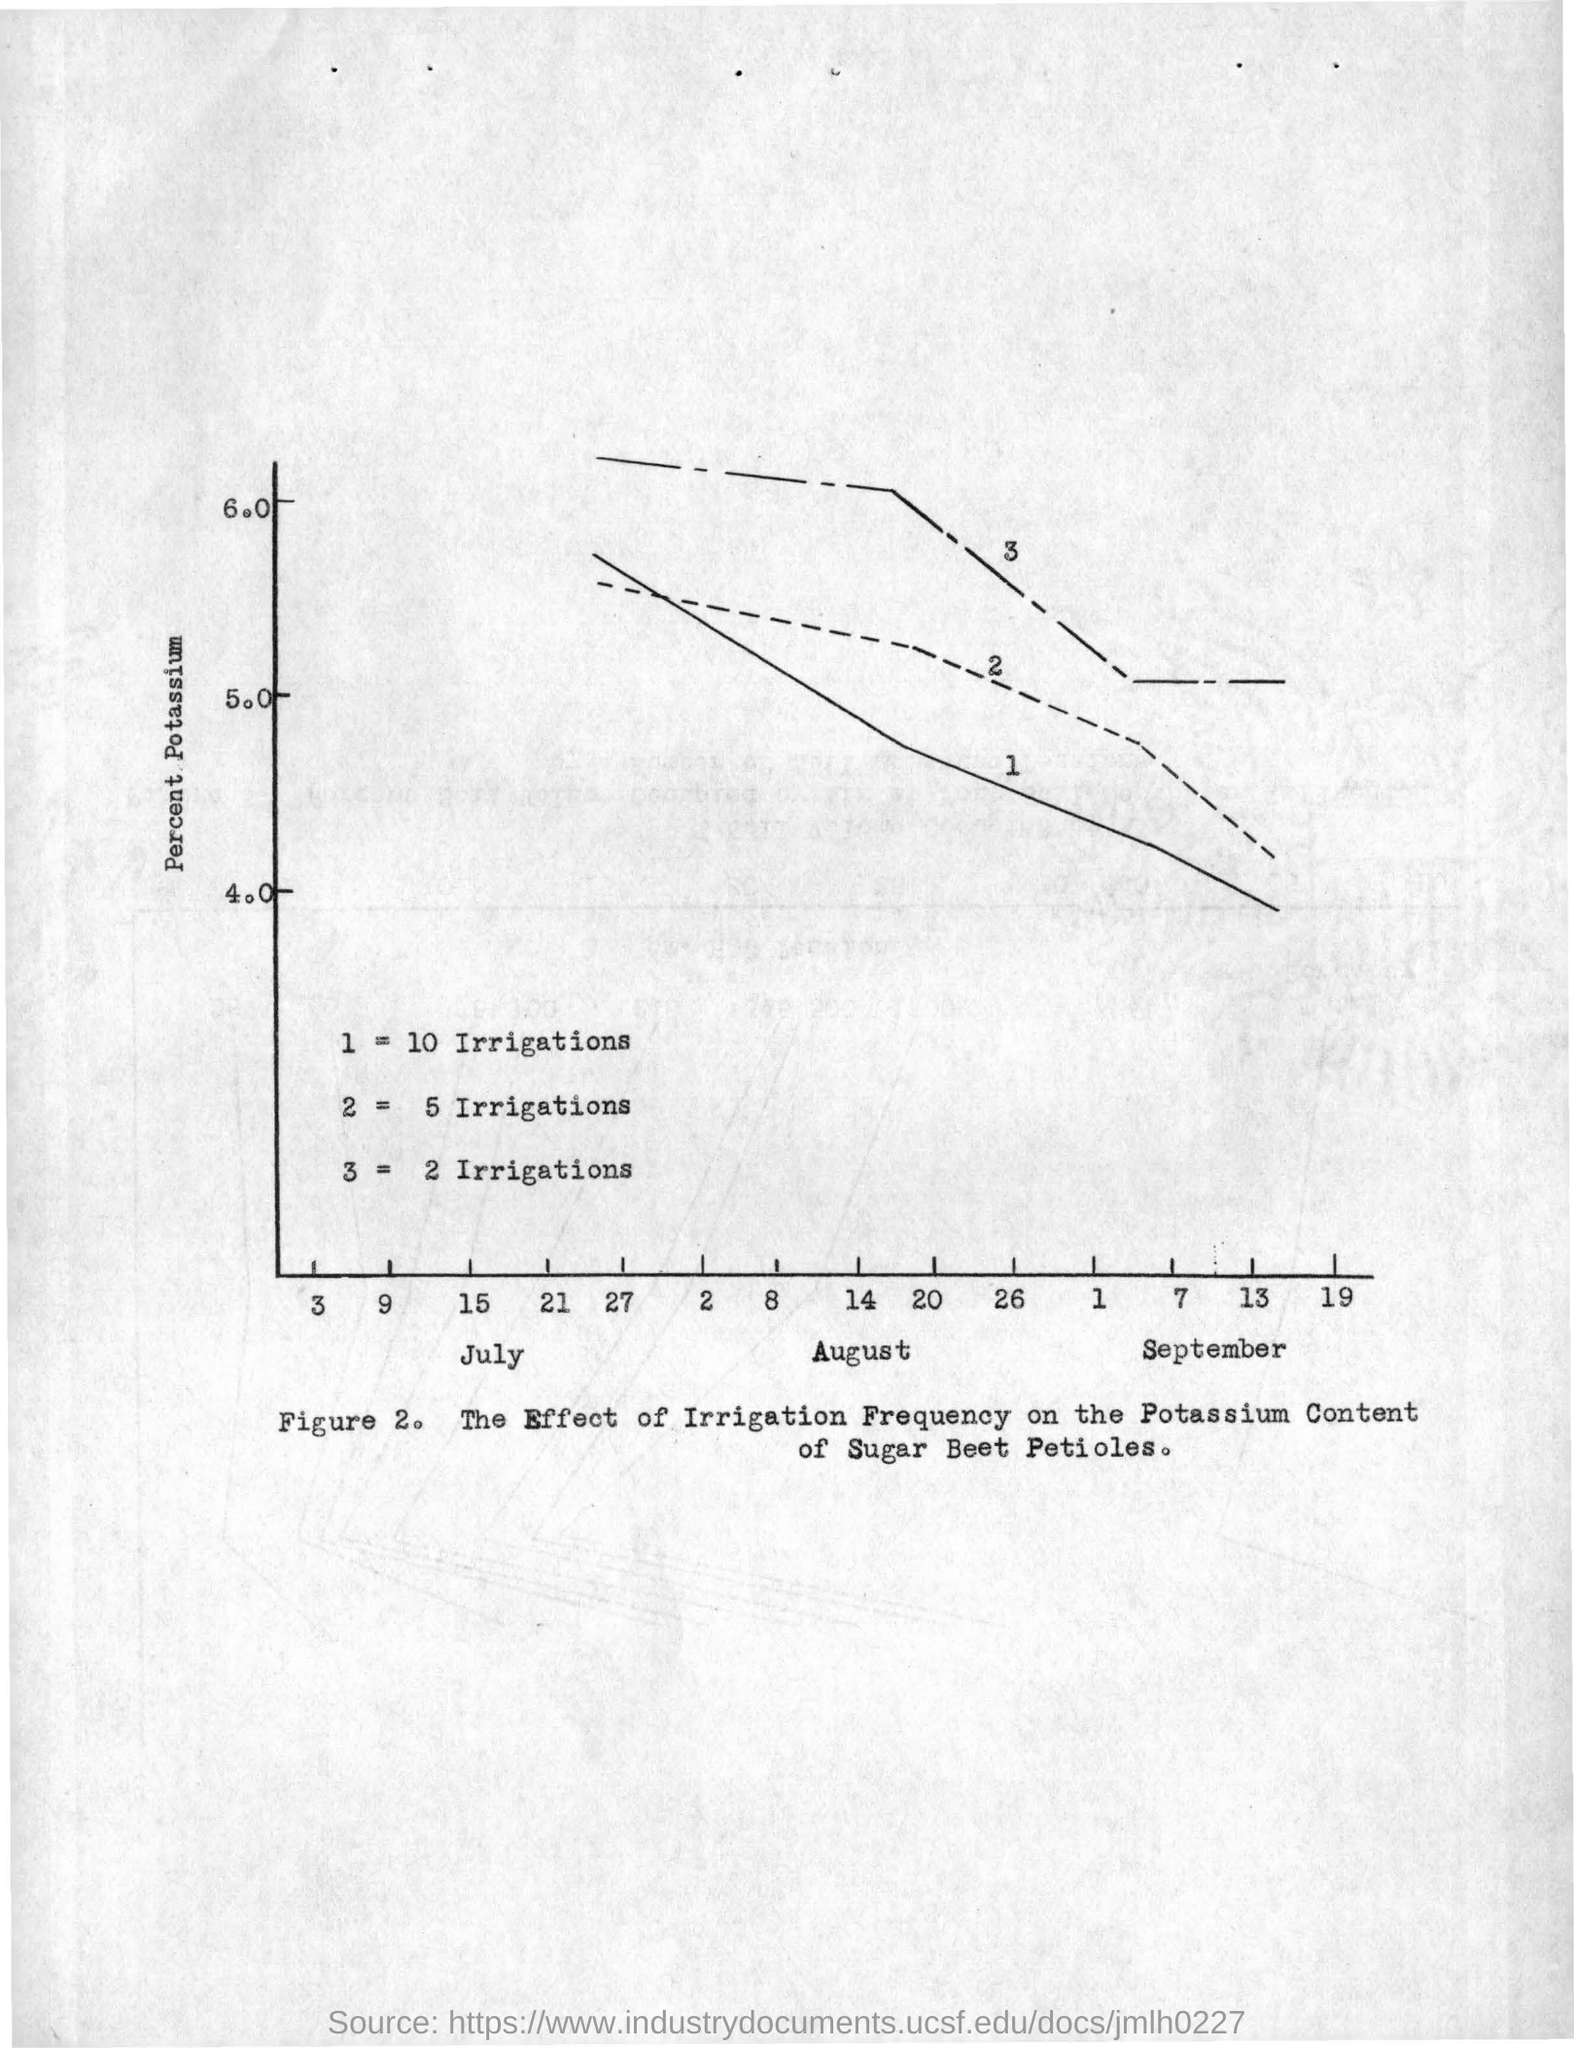Draw attention to some important aspects in this diagram. The y-axis in the graph shows the percentage of potassium in the soil. 